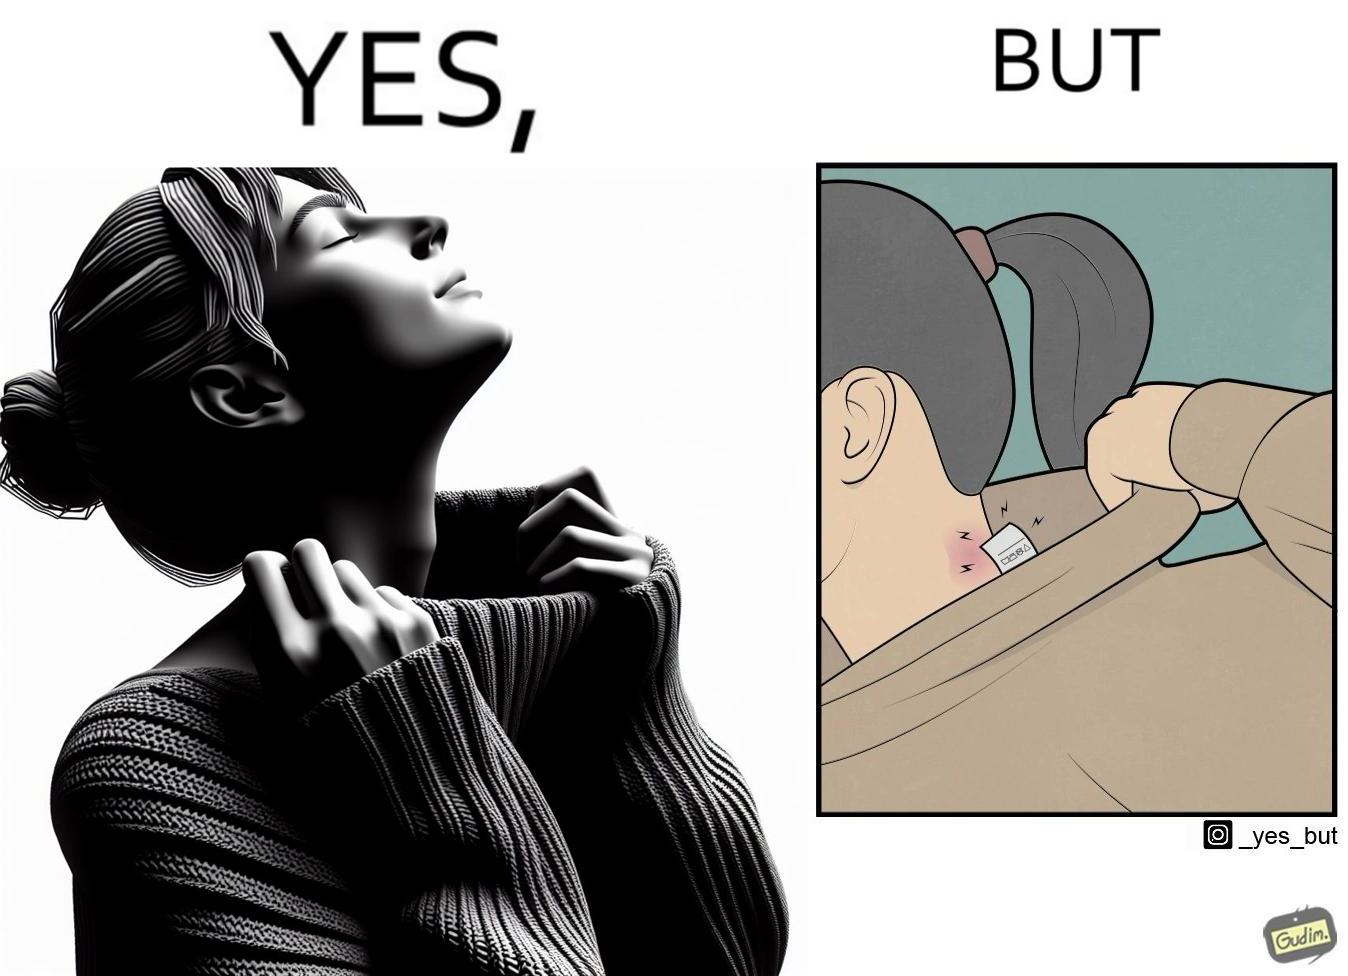What do you see in each half of this image? In the left part of the image: It is a woman enjoying the warmth and comfort of her sweater In the right part of the image: It a womans neck, irritated and red due to manufacturers tags on her clothes 